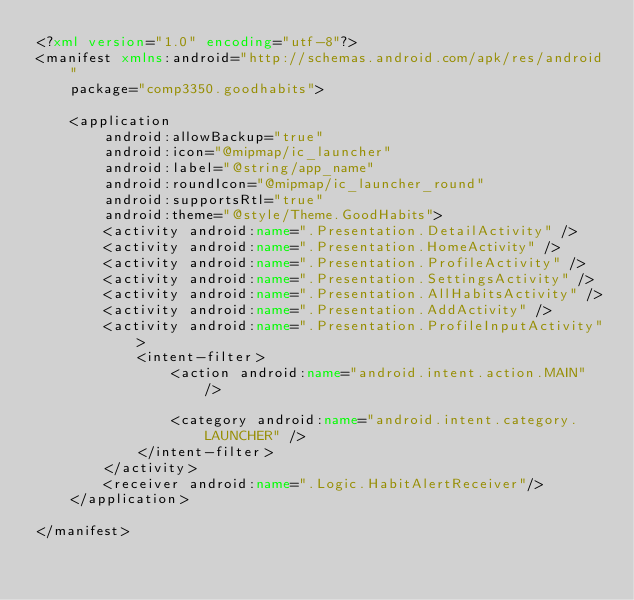<code> <loc_0><loc_0><loc_500><loc_500><_XML_><?xml version="1.0" encoding="utf-8"?>
<manifest xmlns:android="http://schemas.android.com/apk/res/android"
    package="comp3350.goodhabits">

    <application
        android:allowBackup="true"
        android:icon="@mipmap/ic_launcher"
        android:label="@string/app_name"
        android:roundIcon="@mipmap/ic_launcher_round"
        android:supportsRtl="true"
        android:theme="@style/Theme.GoodHabits">
        <activity android:name=".Presentation.DetailActivity" />
        <activity android:name=".Presentation.HomeActivity" />
        <activity android:name=".Presentation.ProfileActivity" />
        <activity android:name=".Presentation.SettingsActivity" />
        <activity android:name=".Presentation.AllHabitsActivity" />
        <activity android:name=".Presentation.AddActivity" />
        <activity android:name=".Presentation.ProfileInputActivity">
            <intent-filter>
                <action android:name="android.intent.action.MAIN" />

                <category android:name="android.intent.category.LAUNCHER" />
            </intent-filter>
        </activity>
        <receiver android:name=".Logic.HabitAlertReceiver"/>
    </application>

</manifest></code> 